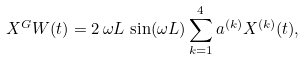<formula> <loc_0><loc_0><loc_500><loc_500>X ^ { G } W ( t ) = 2 \, \omega L \, \sin ( \omega L ) \sum _ { k = 1 } ^ { 4 } a ^ { ( k ) } X ^ { ( k ) } ( t ) ,</formula> 